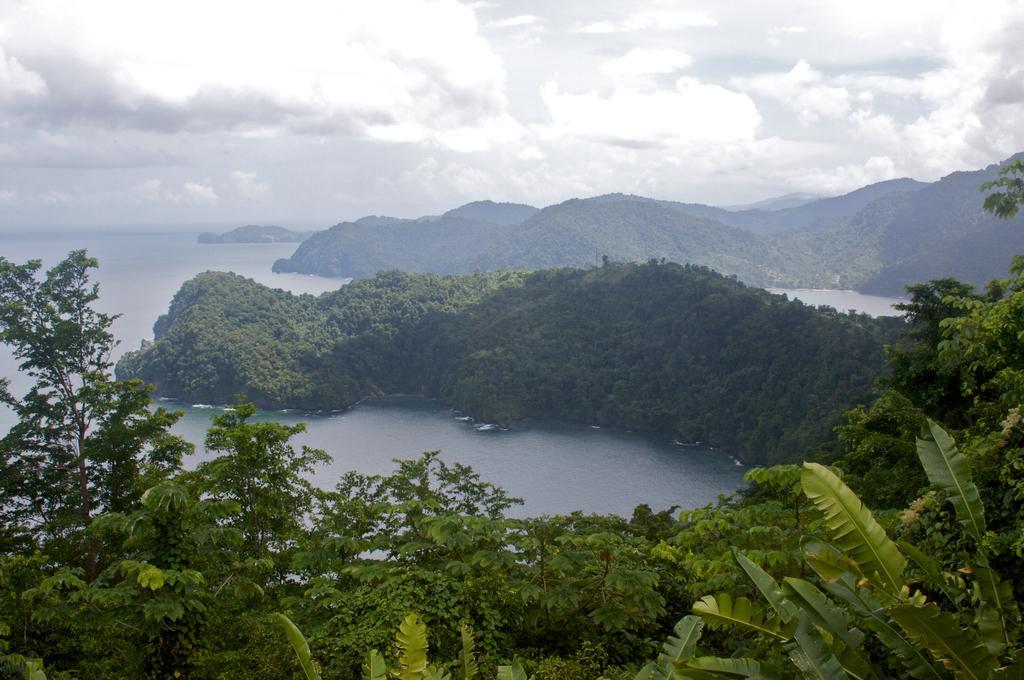Can you describe this image briefly? This picture shows a cloudy sky and we see trees and a hill and we see a water. 